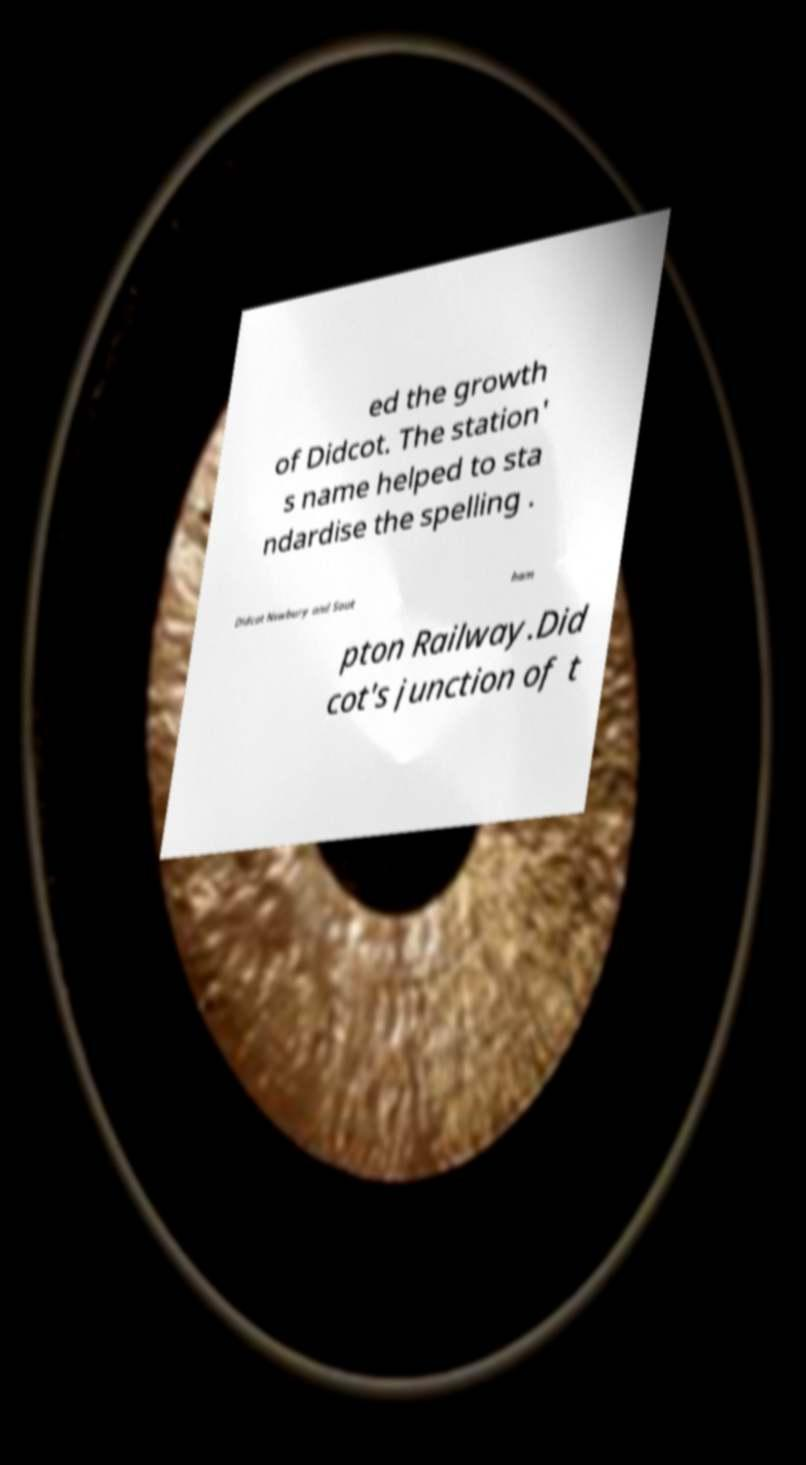For documentation purposes, I need the text within this image transcribed. Could you provide that? ed the growth of Didcot. The station' s name helped to sta ndardise the spelling . Didcot Newbury and Sout ham pton Railway.Did cot's junction of t 